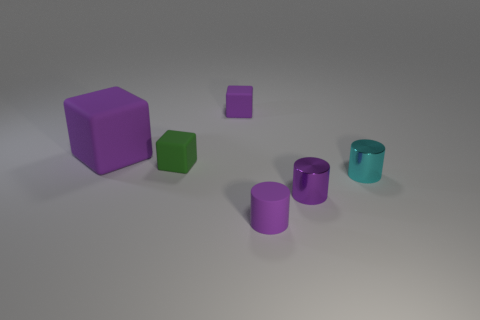Subtract all purple cylinders. How many were subtracted if there are1purple cylinders left? 1 Subtract all small metallic cylinders. How many cylinders are left? 1 Subtract all green cubes. How many cubes are left? 2 Add 1 small cyan cylinders. How many objects exist? 7 Subtract all cyan balls. How many green blocks are left? 1 Subtract all small rubber objects. Subtract all large purple matte cubes. How many objects are left? 2 Add 6 tiny green cubes. How many tiny green cubes are left? 7 Add 4 purple blocks. How many purple blocks exist? 6 Subtract 0 blue spheres. How many objects are left? 6 Subtract 3 cubes. How many cubes are left? 0 